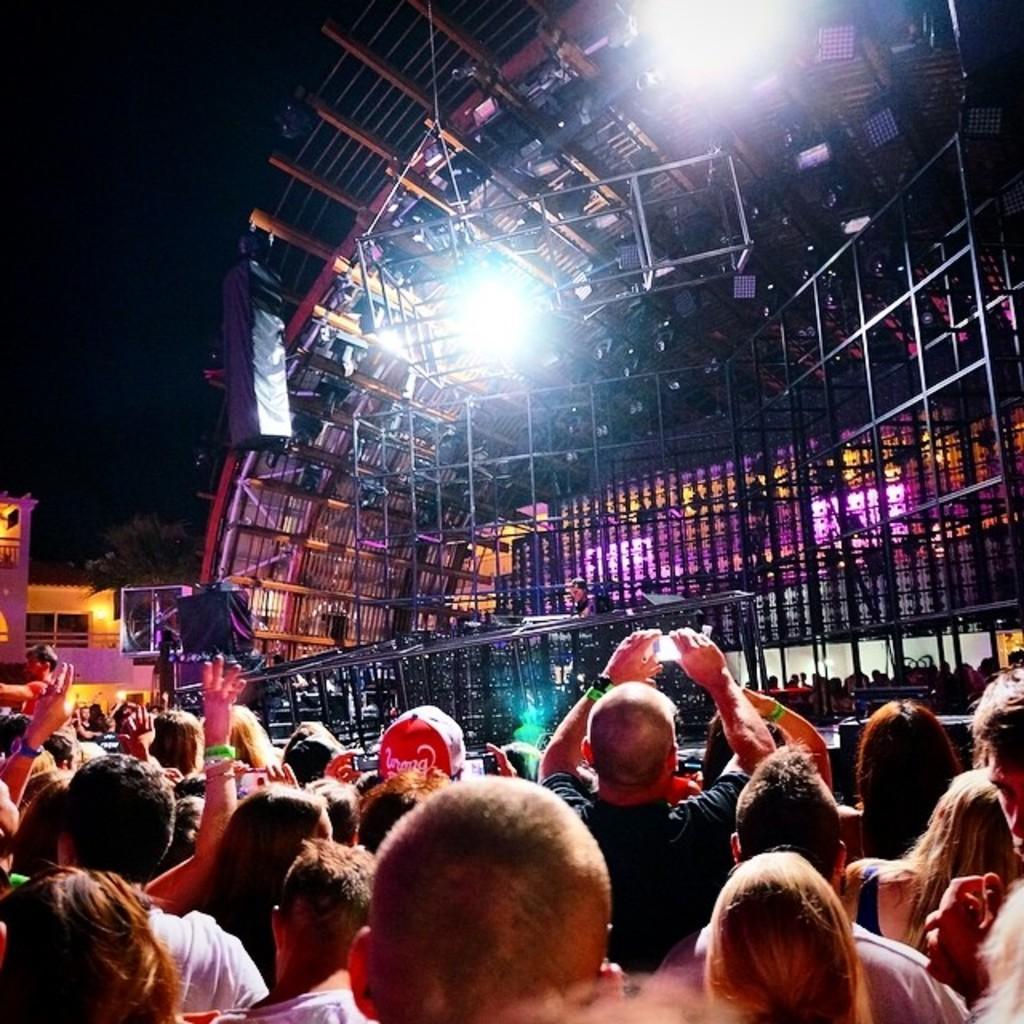In one or two sentences, can you explain what this image depicts? In this image I can see number of people are standing in the front. In the background I can see a stage, number of poles and on the top side of this image I can see few lights. 